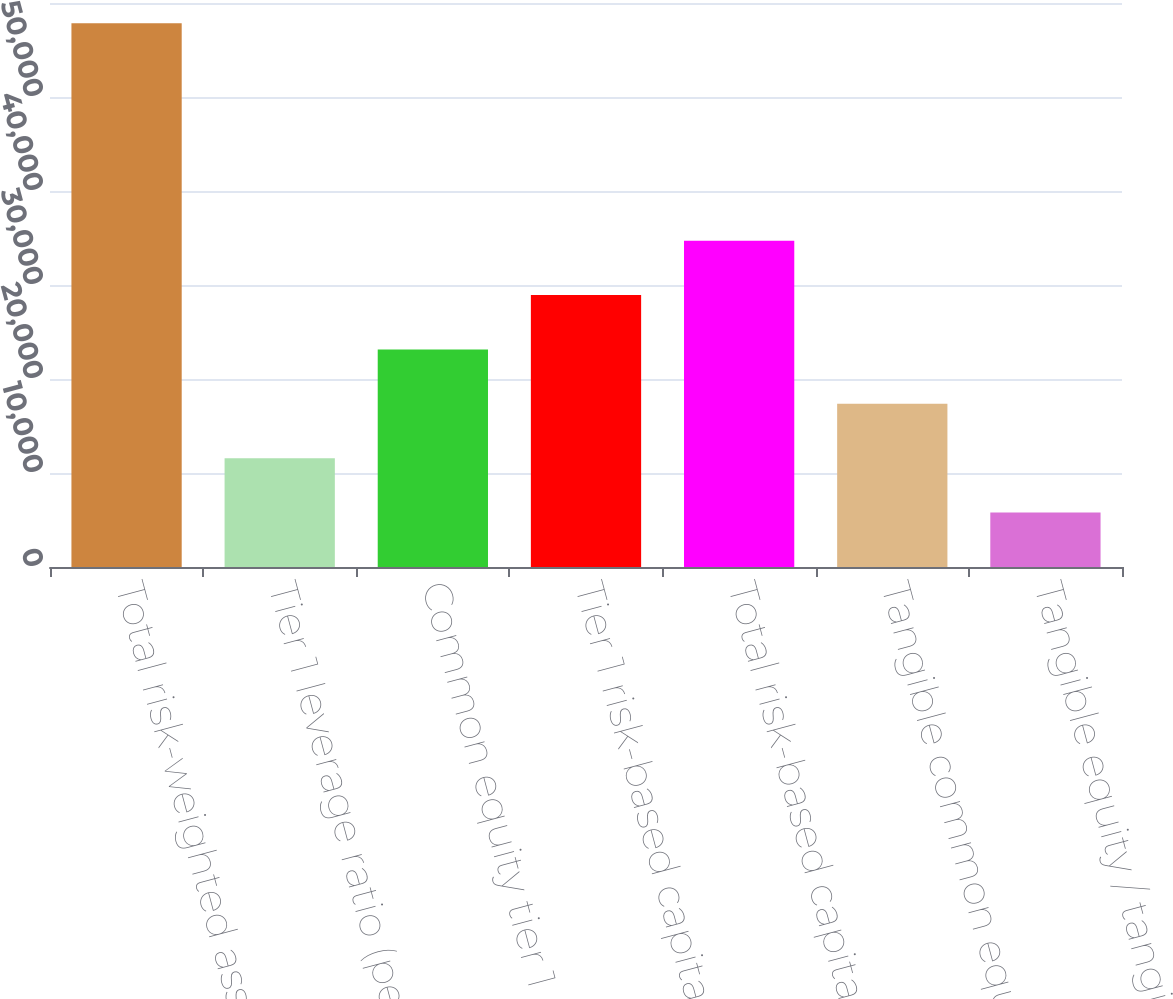Convert chart to OTSL. <chart><loc_0><loc_0><loc_500><loc_500><bar_chart><fcel>Total risk-weighted assets (in<fcel>Tier 1 leverage ratio (period<fcel>Common equity tier 1<fcel>Tier 1 risk-based capital<fcel>Total risk-based capital ratio<fcel>Tangible common equity /<fcel>Tangible equity / tangible<nl><fcel>57839<fcel>11574.1<fcel>23140.3<fcel>28923.4<fcel>34706.6<fcel>17357.2<fcel>5791<nl></chart> 